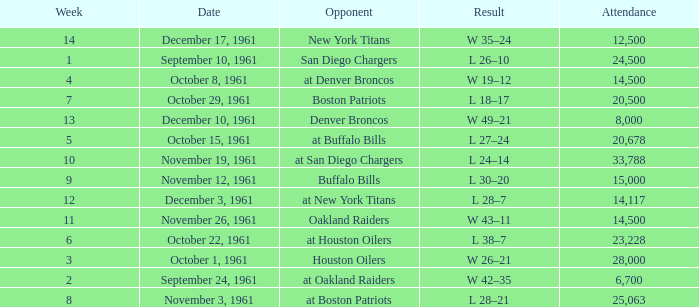What is the low week from october 15, 1961? 5.0. 